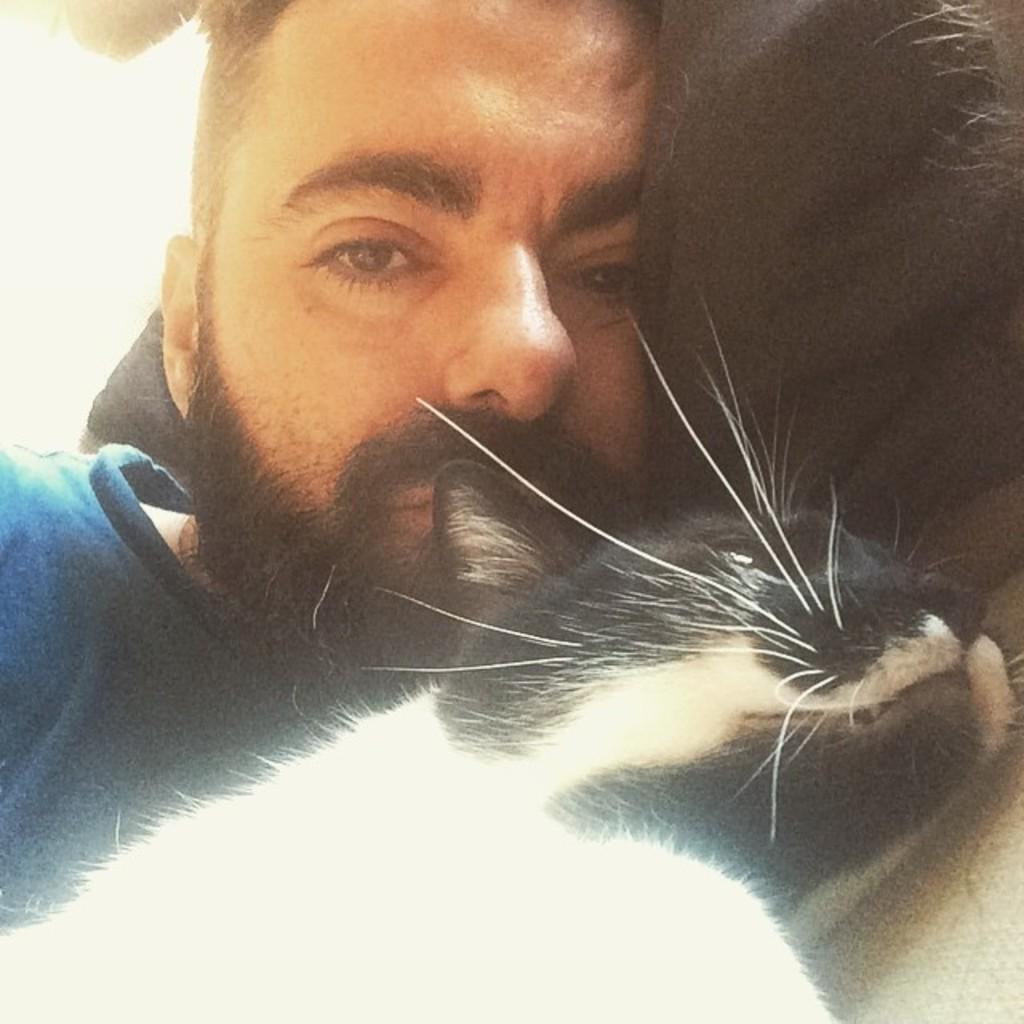Please provide a concise description of this image. This image consists of a man sleeping. He is wearing blue T-shirt. Beside him there is a cat in black and white color. Both are sleeping on the floor. 